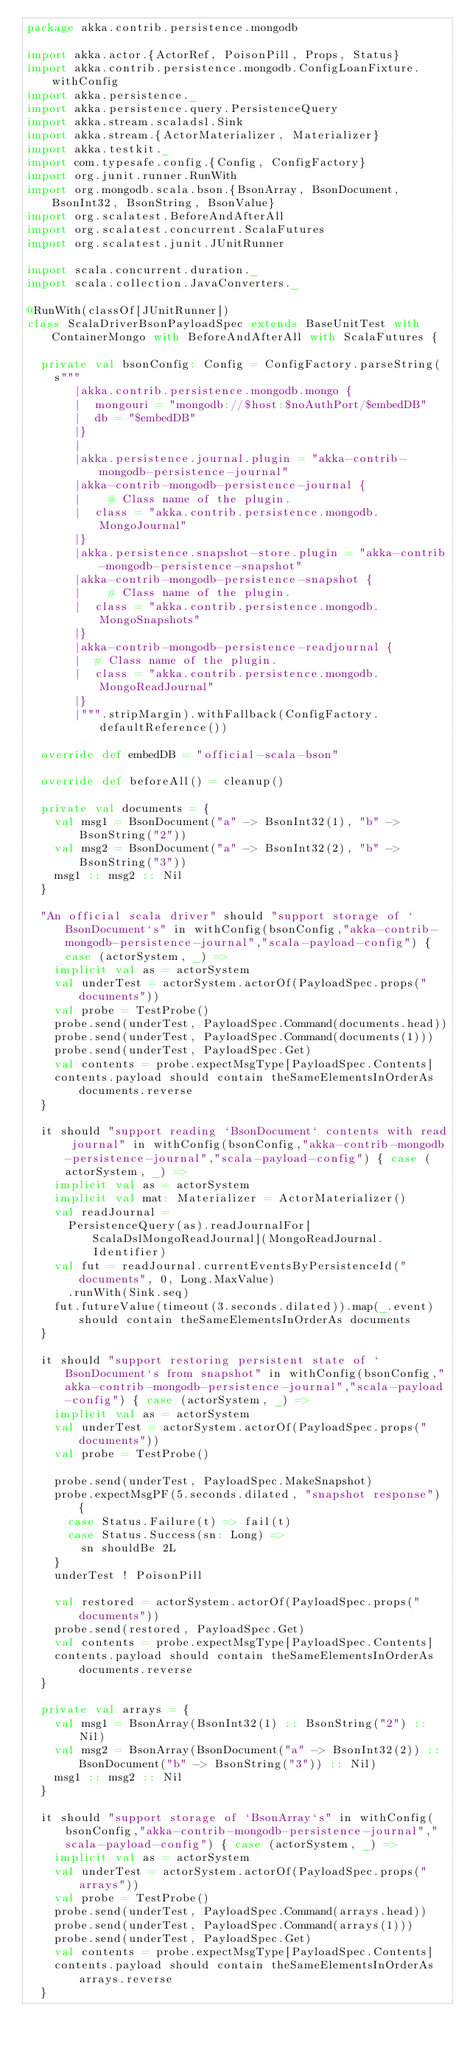<code> <loc_0><loc_0><loc_500><loc_500><_Scala_>package akka.contrib.persistence.mongodb

import akka.actor.{ActorRef, PoisonPill, Props, Status}
import akka.contrib.persistence.mongodb.ConfigLoanFixture.withConfig
import akka.persistence._
import akka.persistence.query.PersistenceQuery
import akka.stream.scaladsl.Sink
import akka.stream.{ActorMaterializer, Materializer}
import akka.testkit._
import com.typesafe.config.{Config, ConfigFactory}
import org.junit.runner.RunWith
import org.mongodb.scala.bson.{BsonArray, BsonDocument, BsonInt32, BsonString, BsonValue}
import org.scalatest.BeforeAndAfterAll
import org.scalatest.concurrent.ScalaFutures
import org.scalatest.junit.JUnitRunner

import scala.concurrent.duration._
import scala.collection.JavaConverters._

@RunWith(classOf[JUnitRunner])
class ScalaDriverBsonPayloadSpec extends BaseUnitTest with ContainerMongo with BeforeAndAfterAll with ScalaFutures {

  private val bsonConfig: Config = ConfigFactory.parseString(
    s"""
       |akka.contrib.persistence.mongodb.mongo {
       |  mongouri = "mongodb://$host:$noAuthPort/$embedDB"
       |  db = "$embedDB"
       |}
       |
       |akka.persistence.journal.plugin = "akka-contrib-mongodb-persistence-journal"
       |akka-contrib-mongodb-persistence-journal {
       |    # Class name of the plugin.
       |  class = "akka.contrib.persistence.mongodb.MongoJournal"
       |}
       |akka.persistence.snapshot-store.plugin = "akka-contrib-mongodb-persistence-snapshot"
       |akka-contrib-mongodb-persistence-snapshot {
       |    # Class name of the plugin.
       |  class = "akka.contrib.persistence.mongodb.MongoSnapshots"
       |}
       |akka-contrib-mongodb-persistence-readjournal {
       |  # Class name of the plugin.
       |  class = "akka.contrib.persistence.mongodb.MongoReadJournal"
       |}
       |""".stripMargin).withFallback(ConfigFactory.defaultReference())

  override def embedDB = "official-scala-bson"

  override def beforeAll() = cleanup()

  private val documents = {
    val msg1 = BsonDocument("a" -> BsonInt32(1), "b" -> BsonString("2"))
    val msg2 = BsonDocument("a" -> BsonInt32(2), "b" -> BsonString("3"))
    msg1 :: msg2 :: Nil
  }

  "An official scala driver" should "support storage of `BsonDocument`s" in withConfig(bsonConfig,"akka-contrib-mongodb-persistence-journal","scala-payload-config") { case (actorSystem, _) =>
    implicit val as = actorSystem
    val underTest = actorSystem.actorOf(PayloadSpec.props("documents"))
    val probe = TestProbe()
    probe.send(underTest, PayloadSpec.Command(documents.head))
    probe.send(underTest, PayloadSpec.Command(documents(1)))
    probe.send(underTest, PayloadSpec.Get)
    val contents = probe.expectMsgType[PayloadSpec.Contents]
    contents.payload should contain theSameElementsInOrderAs documents.reverse
  }

  it should "support reading `BsonDocument` contents with read journal" in withConfig(bsonConfig,"akka-contrib-mongodb-persistence-journal","scala-payload-config") { case (actorSystem, _) =>
    implicit val as = actorSystem
    implicit val mat: Materializer = ActorMaterializer()
    val readJournal =
      PersistenceQuery(as).readJournalFor[ScalaDslMongoReadJournal](MongoReadJournal.Identifier)
    val fut = readJournal.currentEventsByPersistenceId("documents", 0, Long.MaxValue)
      .runWith(Sink.seq)
    fut.futureValue(timeout(3.seconds.dilated)).map(_.event) should contain theSameElementsInOrderAs documents
  }

  it should "support restoring persistent state of `BsonDocument`s from snapshot" in withConfig(bsonConfig,"akka-contrib-mongodb-persistence-journal","scala-payload-config") { case (actorSystem, _) =>
    implicit val as = actorSystem
    val underTest = actorSystem.actorOf(PayloadSpec.props("documents"))
    val probe = TestProbe()

    probe.send(underTest, PayloadSpec.MakeSnapshot)
    probe.expectMsgPF(5.seconds.dilated, "snapshot response") {
      case Status.Failure(t) => fail(t)
      case Status.Success(sn: Long) =>
        sn shouldBe 2L
    }
    underTest ! PoisonPill

    val restored = actorSystem.actorOf(PayloadSpec.props("documents"))
    probe.send(restored, PayloadSpec.Get)
    val contents = probe.expectMsgType[PayloadSpec.Contents]
    contents.payload should contain theSameElementsInOrderAs documents.reverse
  }

  private val arrays = {
    val msg1 = BsonArray(BsonInt32(1) :: BsonString("2") :: Nil)
    val msg2 = BsonArray(BsonDocument("a" -> BsonInt32(2)) :: BsonDocument("b" -> BsonString("3")) :: Nil)
    msg1 :: msg2 :: Nil
  }

  it should "support storage of `BsonArray`s" in withConfig(bsonConfig,"akka-contrib-mongodb-persistence-journal","scala-payload-config") { case (actorSystem, _) =>
    implicit val as = actorSystem
    val underTest = actorSystem.actorOf(PayloadSpec.props("arrays"))
    val probe = TestProbe()
    probe.send(underTest, PayloadSpec.Command(arrays.head))
    probe.send(underTest, PayloadSpec.Command(arrays(1)))
    probe.send(underTest, PayloadSpec.Get)
    val contents = probe.expectMsgType[PayloadSpec.Contents]
    contents.payload should contain theSameElementsInOrderAs arrays.reverse
  }
</code> 